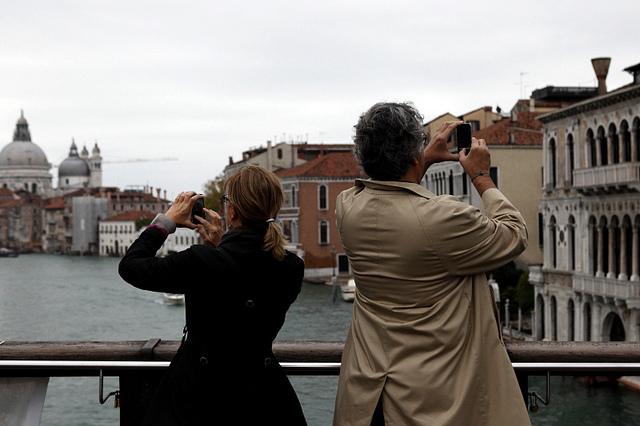What is the woman using with her hands?
Short answer required. Camera. Is it cold outside?
Quick response, please. Yes. What famous city is this?
Keep it brief. Venice. 